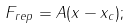Convert formula to latex. <formula><loc_0><loc_0><loc_500><loc_500>F _ { r e p } = A ( x - x _ { c } ) ;</formula> 